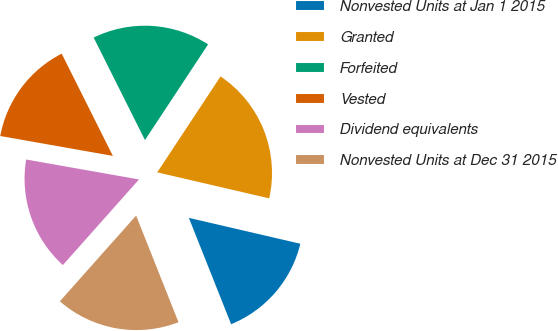<chart> <loc_0><loc_0><loc_500><loc_500><pie_chart><fcel>Nonvested Units at Jan 1 2015<fcel>Granted<fcel>Forfeited<fcel>Vested<fcel>Dividend equivalents<fcel>Nonvested Units at Dec 31 2015<nl><fcel>15.35%<fcel>19.35%<fcel>16.67%<fcel>14.83%<fcel>16.22%<fcel>17.59%<nl></chart> 